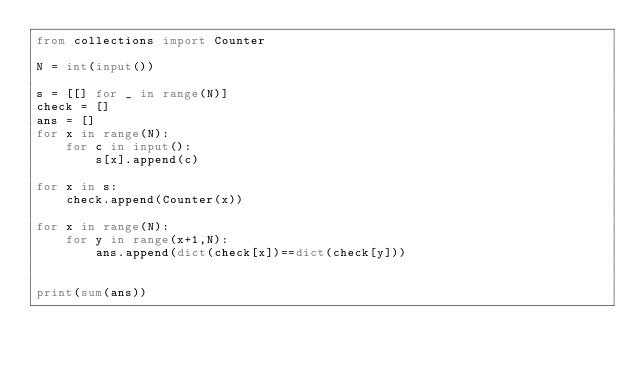Convert code to text. <code><loc_0><loc_0><loc_500><loc_500><_Python_>from collections import Counter

N = int(input())

s = [[] for _ in range(N)]
check = []
ans = []
for x in range(N):
    for c in input():
        s[x].append(c)

for x in s:
    check.append(Counter(x))

for x in range(N):
    for y in range(x+1,N):
        ans.append(dict(check[x])==dict(check[y]))


print(sum(ans))</code> 